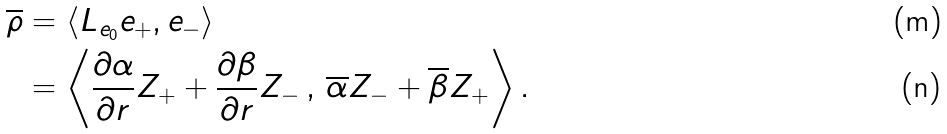<formula> <loc_0><loc_0><loc_500><loc_500>\overline { \rho } & = \left < L _ { e _ { 0 } } e _ { + } , e _ { - } \right > \\ & = \left < \frac { \partial \alpha } { \partial r } Z _ { + } + \frac { \partial \beta } { \partial r } Z _ { - } \, , \, \overline { \alpha } Z _ { - } + \overline { \beta } Z _ { + } \right > .</formula> 